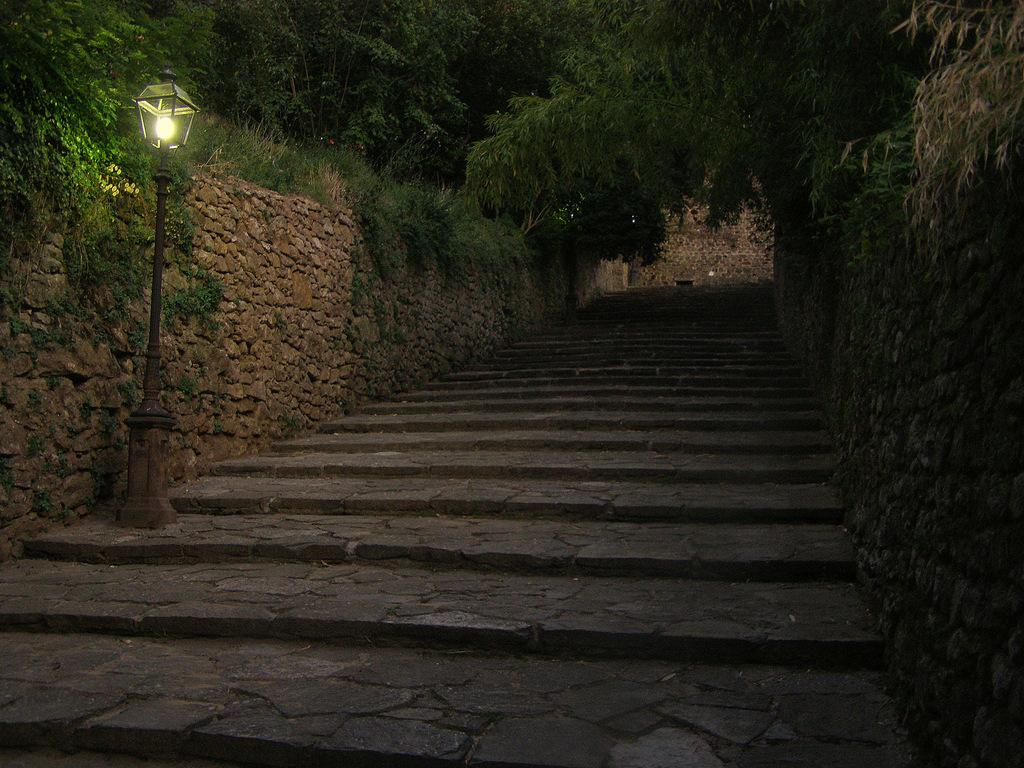At what time of day was the image taken? The image was taken during night time. What is one feature of the image that provides light? There is a light pole in the image. What architectural element can be seen in the image? There are stairs in the image. What type of vegetation is present in the image? There are trees and grass in the image. What type of structure can be seen in the image? There is a stone wall in the image. Can you tell me how many rats are visible on the stone wall in the image? There are no rats visible on the stone wall in the image. What type of comparison can be made between the trees and the grass in the image? There is no comparison being made between the trees and the grass in the image; the question is not relevant to the information provided. 